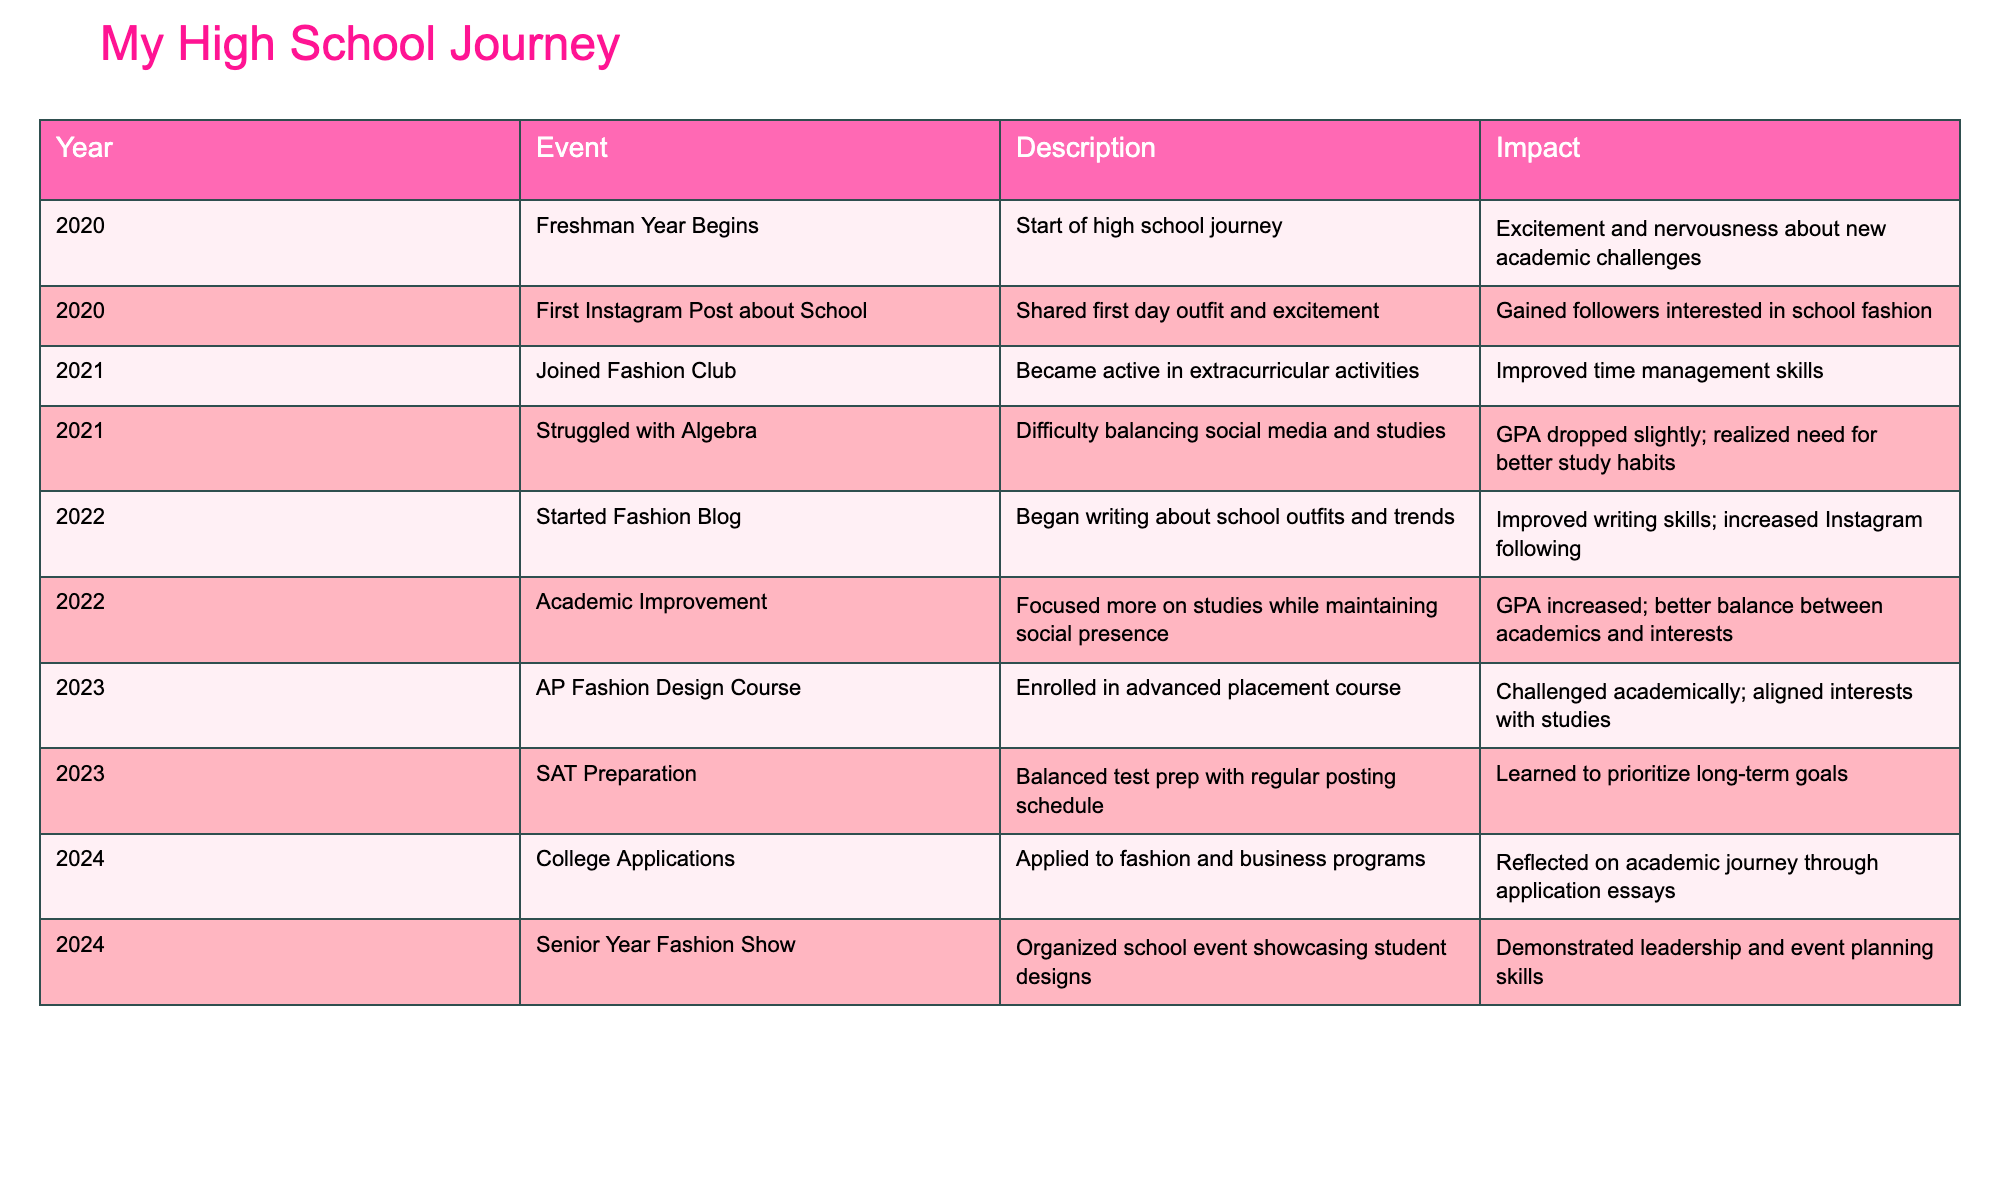What year did your freshman year begin? The table shows the event "Freshman Year Begins" occurring in the year 2020.
Answer: 2020 What positive impact did joining the Fashion Club have? The table indicates that joining the Fashion Club improved time management skills, making it a positive impact.
Answer: Improved time management skills Did your GPA drop while struggling with Algebra? The description for struggling with Algebra states that the GPA dropped slightly, indicating a negative impact during that time.
Answer: Yes In what year did you begin your Fashion Blog? The table reveals that the Fashion Blog was started in 2022, which is the relevant year for this event.
Answer: 2022 What is the impact of focusing more on studies in 2022? The table states that focusing more on studies while maintaining social media presence led to an improved GPA, indicating a significant positive impact.
Answer: Improved GPA How many events improved your academic performance from 2021 to 2022? There are two events relevant to academic performance improvement: "Struggled with Algebra" in 2021, which caused a GPA drop, and "Academic Improvement" in 2022, which indicates a GPA increase. Thus, the overall outcome reveals one significant event leading to improvement.
Answer: 1 event What events showcase leadership or planning skills? The table lists the "Senior Year Fashion Show" in 2024 as the only event that demonstrates leadership and event planning skills. It’s a key indicator of a leadership role among peers.
Answer: 1 event Which year had the highest focus on balancing school and Instagram? The events in 2022 (Fashion Blog and Academic Improvement) highlight a strong balance. However, 2023 also includes SAT Preparation alongside posting, making it also relevant. It requires considering multiple years; therefore, both years show a balanced approach.
Answer: 2022 and 2023 How did enrolling in the AP Fashion Design Course challenge you academically? The details indicate enrollment in the AP course in 2023 and mention challenging academically while aligning interests with studies, showing that it pushed personal boundaries in learning.
Answer: It challenged personal academic boundaries 